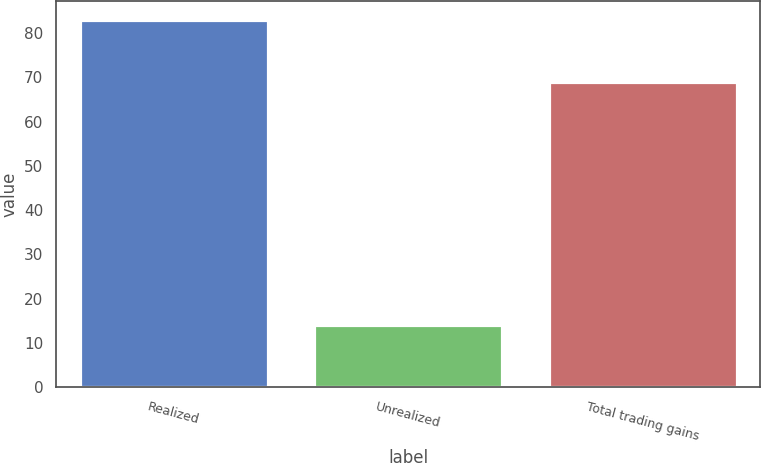<chart> <loc_0><loc_0><loc_500><loc_500><bar_chart><fcel>Realized<fcel>Unrealized<fcel>Total trading gains<nl><fcel>83<fcel>14<fcel>69<nl></chart> 